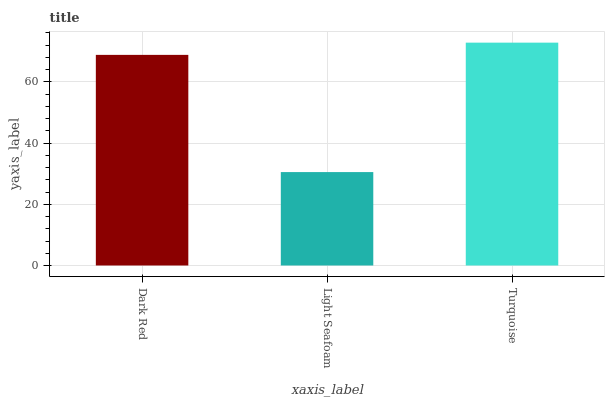Is Light Seafoam the minimum?
Answer yes or no. Yes. Is Turquoise the maximum?
Answer yes or no. Yes. Is Turquoise the minimum?
Answer yes or no. No. Is Light Seafoam the maximum?
Answer yes or no. No. Is Turquoise greater than Light Seafoam?
Answer yes or no. Yes. Is Light Seafoam less than Turquoise?
Answer yes or no. Yes. Is Light Seafoam greater than Turquoise?
Answer yes or no. No. Is Turquoise less than Light Seafoam?
Answer yes or no. No. Is Dark Red the high median?
Answer yes or no. Yes. Is Dark Red the low median?
Answer yes or no. Yes. Is Turquoise the high median?
Answer yes or no. No. Is Turquoise the low median?
Answer yes or no. No. 